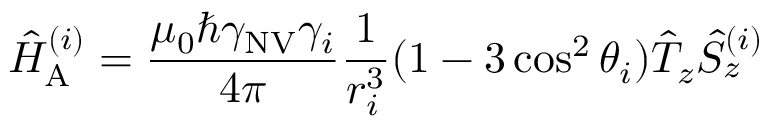Convert formula to latex. <formula><loc_0><loc_0><loc_500><loc_500>\hat { H } _ { A } ^ { ( i ) } = \frac { \mu _ { 0 } \hbar { \gamma } _ { N V } \gamma _ { i } } { 4 \pi } \frac { 1 } { r _ { i } ^ { 3 } } ( 1 - 3 \cos ^ { 2 } { \theta _ { i } } ) \hat { T } _ { z } \hat { S } _ { z } ^ { ( i ) }</formula> 